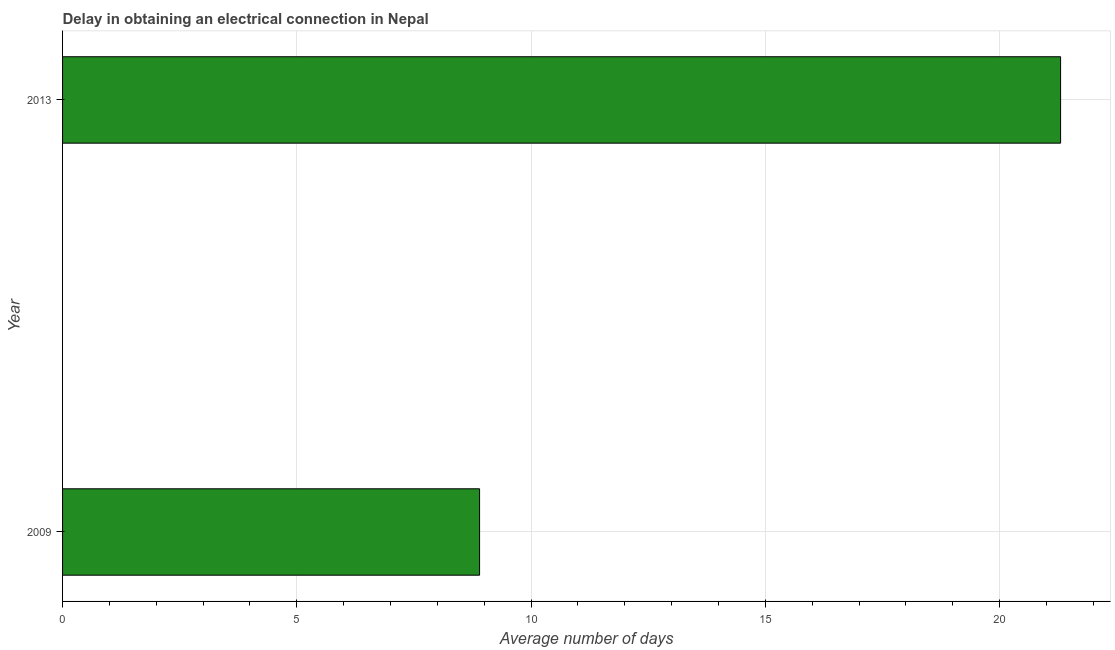What is the title of the graph?
Your response must be concise. Delay in obtaining an electrical connection in Nepal. What is the label or title of the X-axis?
Make the answer very short. Average number of days. What is the label or title of the Y-axis?
Give a very brief answer. Year. What is the dalay in electrical connection in 2013?
Ensure brevity in your answer.  21.3. Across all years, what is the maximum dalay in electrical connection?
Provide a succinct answer. 21.3. Across all years, what is the minimum dalay in electrical connection?
Ensure brevity in your answer.  8.9. In which year was the dalay in electrical connection maximum?
Your answer should be very brief. 2013. What is the sum of the dalay in electrical connection?
Your answer should be very brief. 30.2. What is the difference between the dalay in electrical connection in 2009 and 2013?
Your response must be concise. -12.4. What is the median dalay in electrical connection?
Ensure brevity in your answer.  15.1. Do a majority of the years between 2009 and 2013 (inclusive) have dalay in electrical connection greater than 18 days?
Make the answer very short. No. What is the ratio of the dalay in electrical connection in 2009 to that in 2013?
Provide a short and direct response. 0.42. Are all the bars in the graph horizontal?
Your answer should be compact. Yes. What is the difference between two consecutive major ticks on the X-axis?
Make the answer very short. 5. What is the Average number of days of 2009?
Your answer should be very brief. 8.9. What is the Average number of days of 2013?
Your response must be concise. 21.3. What is the ratio of the Average number of days in 2009 to that in 2013?
Make the answer very short. 0.42. 